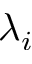Convert formula to latex. <formula><loc_0><loc_0><loc_500><loc_500>\lambda _ { i }</formula> 